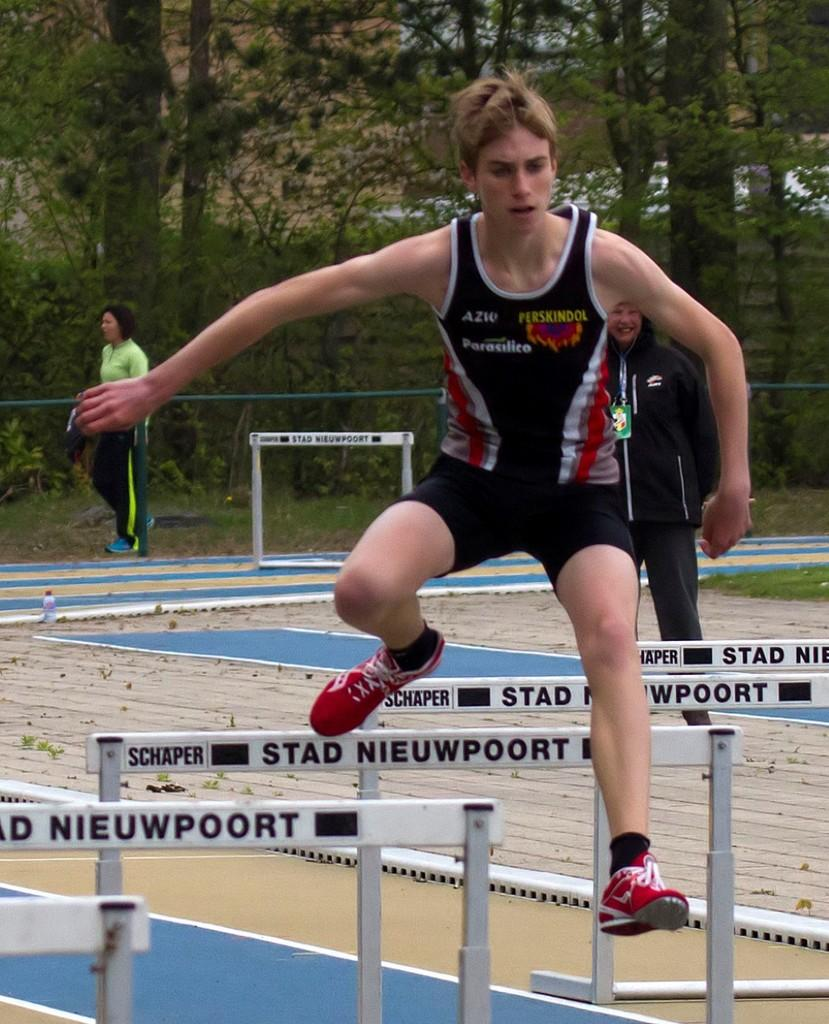<image>
Offer a succinct explanation of the picture presented. A teenager is jumping over hurdles which are labeled Stad Nieuwpoort. 